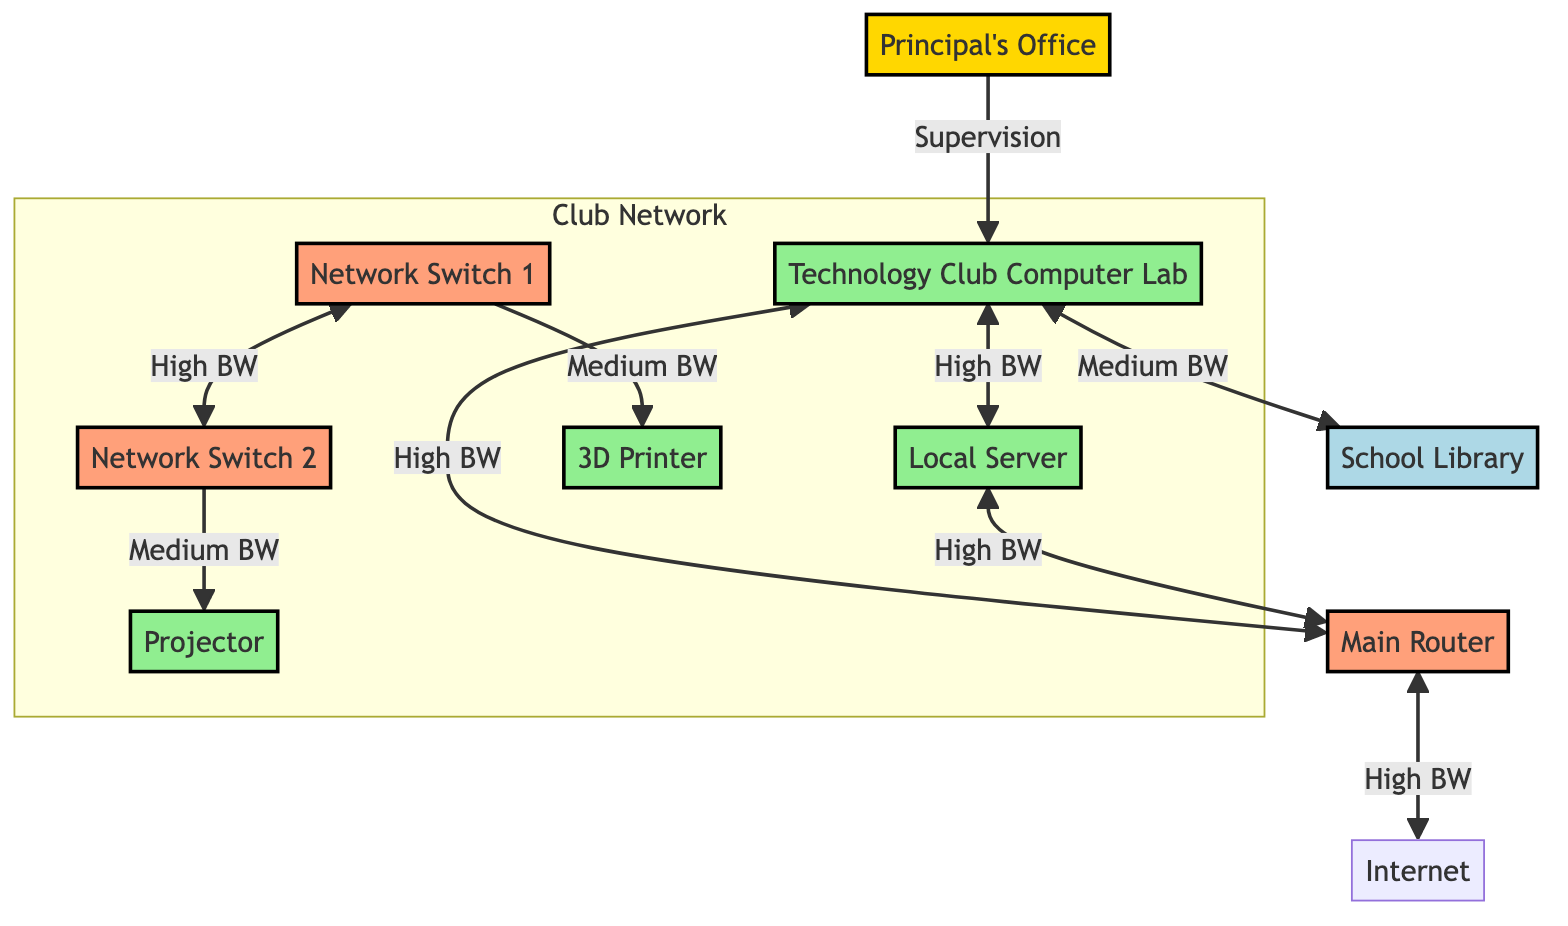What is the main resource for the club members? The main resource for the club members, as indicated in the diagram, is the Technology Club Computer Lab. It is designated as a resource node, highlighting its significance as the primary workspace.
Answer: Technology Club Computer Lab How many network switches are present in the diagram? There are two network switches present in the diagram, as represented by the nodes labeled Network Switch 1 and Network Switch 2. Each switch is associated with different connections.
Answer: 2 What type of connection links the Technology Club Computer Lab and the School Library? The type of connection that links the Technology Club Computer Lab and the School Library is labeled as a Network Connection. This indicates that they are interconnected within the network.
Answer: Network Connection What is the bandwidth of the connection between the Local Server and the Main Router? The bandwidth of the connection between the Local Server and the Main Router is defined as High, indicating a strong connection quality for data transfer between these two elements.
Answer: High Which node provides internet access in the diagram? The node that provides internet access in the diagram is the Main Router, as it connects to the internet and facilitates external access for the club.
Answer: Main Router How are the two network switches connected to each other? The two network switches are connected to each other through a High bandwidth link that serves as Network Redundancy, showcasing a backup connection for improved reliability.
Answer: High bandwidth What role does the Principal's Office play in the Technology Club network? The Principal's Office plays the role of a Supervisor within the Technology Club network, overseeing the club's activities and ensuring proper resource allocation and management.
Answer: Supervisor What resources are classified as Peripheral Connections in the diagram? The resources classified as Peripheral Connections in the diagram include the 3D Printer and the Projector, which are both connected via different network switches for functionality.
Answer: 3D Printer and Projector 